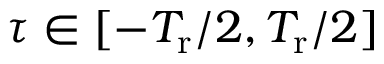<formula> <loc_0><loc_0><loc_500><loc_500>\tau \in [ - T _ { r } / 2 , T _ { r } / 2 ]</formula> 